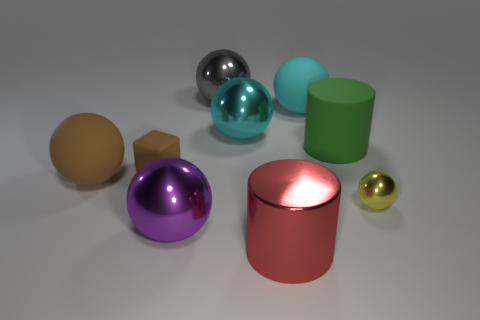Subtract 3 spheres. How many spheres are left? 3 Subtract all brown spheres. How many spheres are left? 5 Subtract all large purple metal balls. How many balls are left? 5 Subtract all red spheres. Subtract all blue blocks. How many spheres are left? 6 Add 1 green rubber cylinders. How many objects exist? 10 Subtract all balls. How many objects are left? 3 Add 6 big gray shiny objects. How many big gray shiny objects exist? 7 Subtract 1 cyan balls. How many objects are left? 8 Subtract all big red matte spheres. Subtract all small rubber blocks. How many objects are left? 8 Add 7 large green cylinders. How many large green cylinders are left? 8 